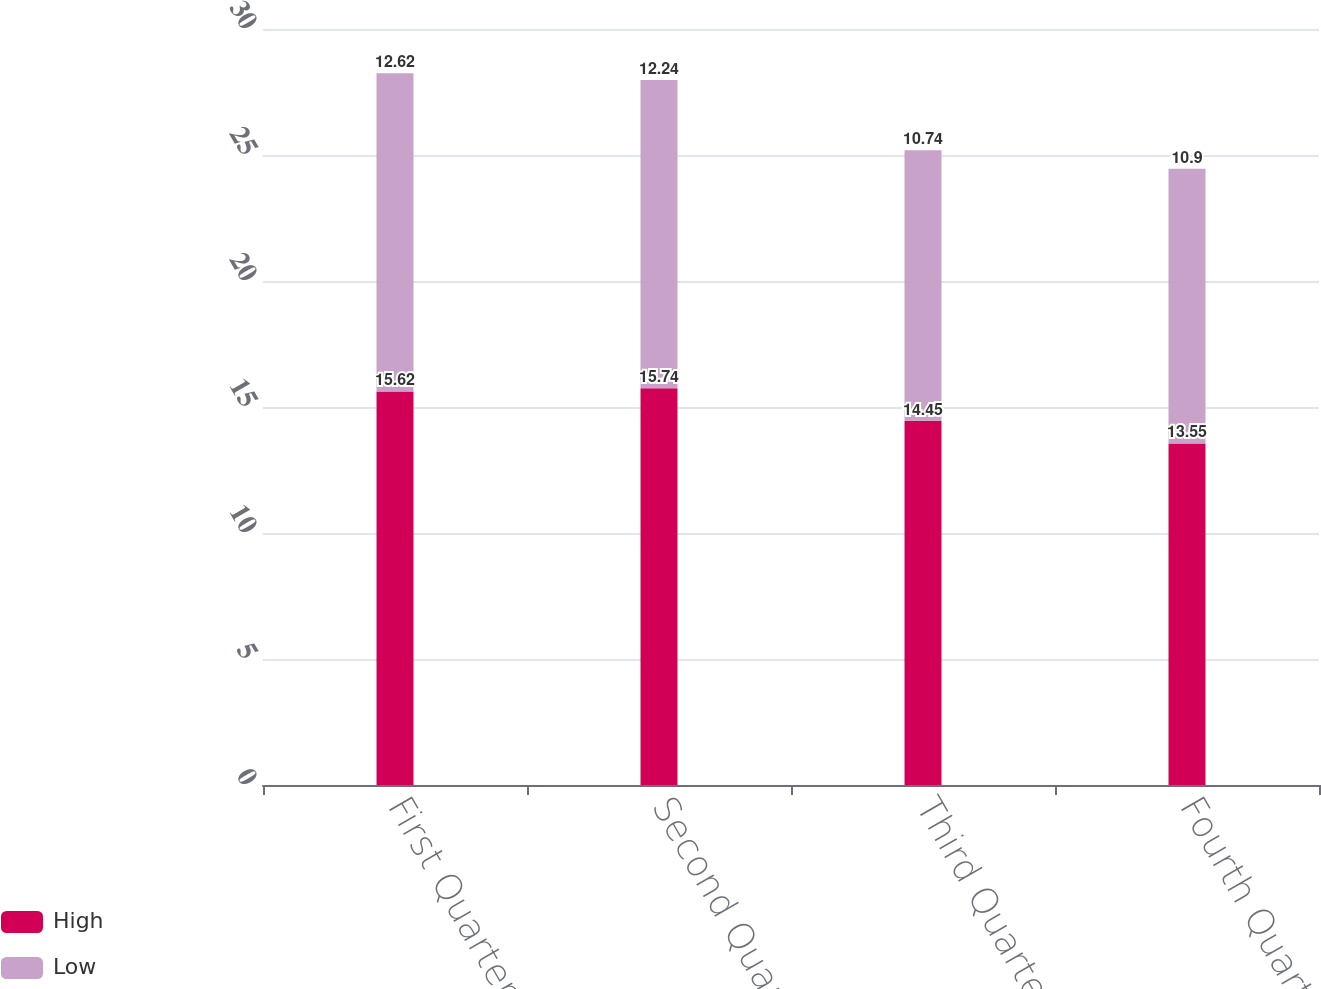Convert chart to OTSL. <chart><loc_0><loc_0><loc_500><loc_500><stacked_bar_chart><ecel><fcel>First Quarter<fcel>Second Quarter<fcel>Third Quarter<fcel>Fourth Quarter<nl><fcel>High<fcel>15.62<fcel>15.74<fcel>14.45<fcel>13.55<nl><fcel>Low<fcel>12.62<fcel>12.24<fcel>10.74<fcel>10.9<nl></chart> 